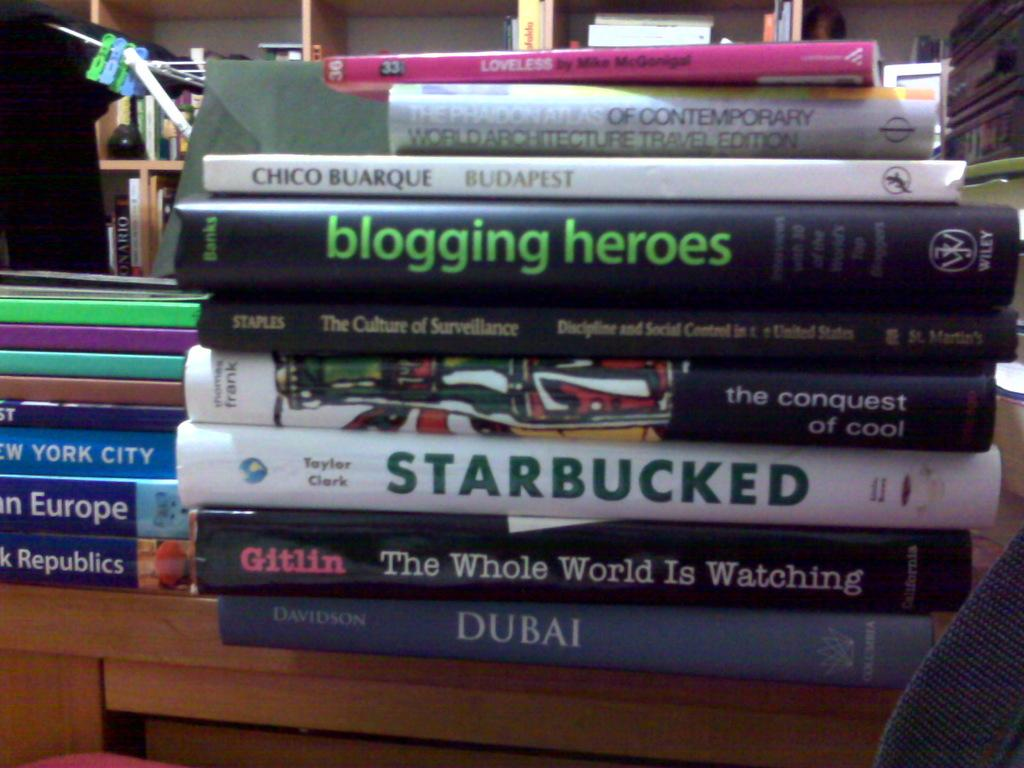<image>
Write a terse but informative summary of the picture. The book Dubai is under a stack of other books. 